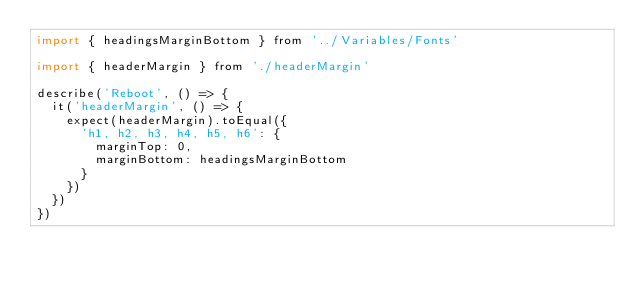Convert code to text. <code><loc_0><loc_0><loc_500><loc_500><_JavaScript_>import { headingsMarginBottom } from '../Variables/Fonts'

import { headerMargin } from './headerMargin'

describe('Reboot', () => {
  it('headerMargin', () => {
    expect(headerMargin).toEqual({
      'h1, h2, h3, h4, h5, h6': {
        marginTop: 0,
        marginBottom: headingsMarginBottom
      }
    })
  })
})
</code> 